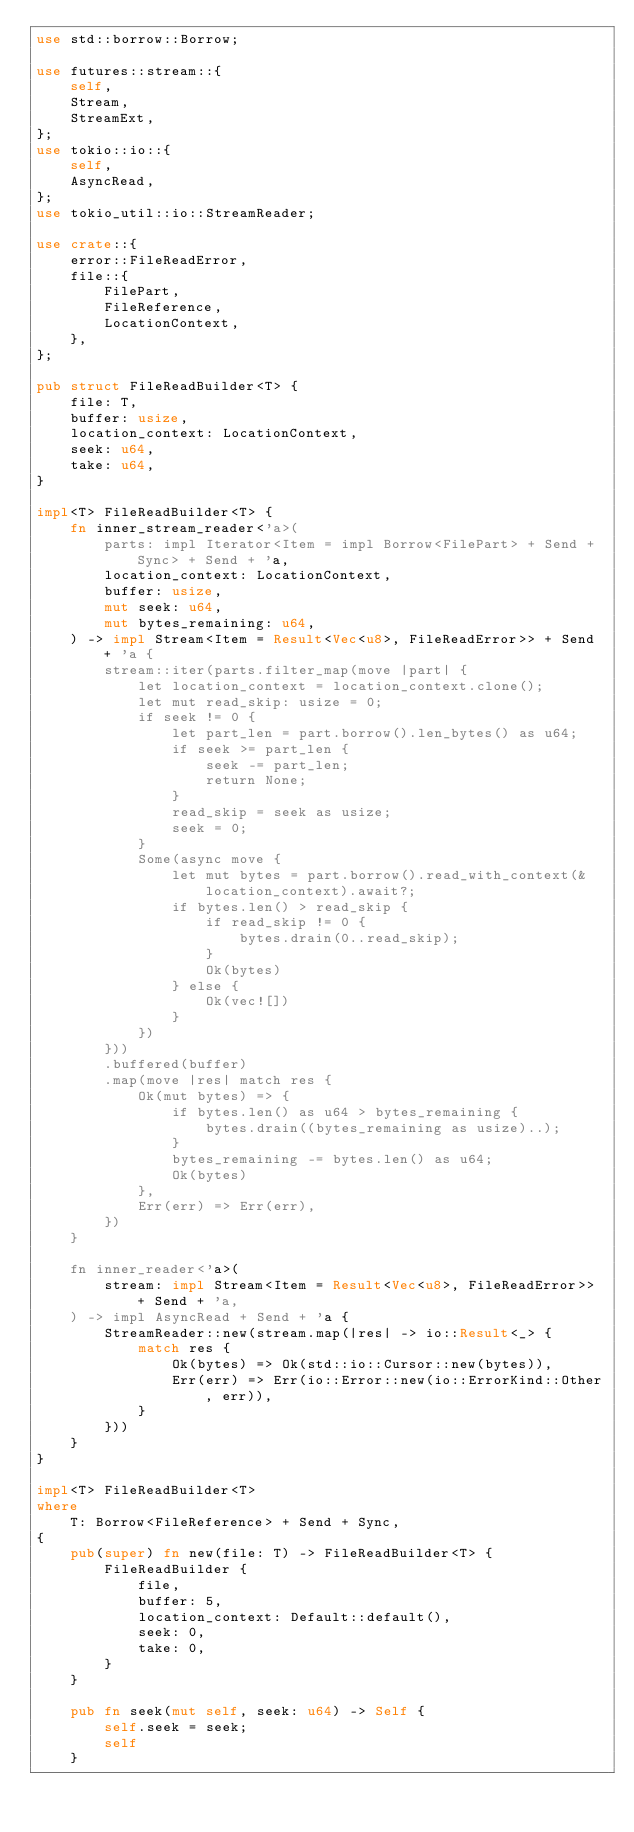<code> <loc_0><loc_0><loc_500><loc_500><_Rust_>use std::borrow::Borrow;

use futures::stream::{
    self,
    Stream,
    StreamExt,
};
use tokio::io::{
    self,
    AsyncRead,
};
use tokio_util::io::StreamReader;

use crate::{
    error::FileReadError,
    file::{
        FilePart,
        FileReference,
        LocationContext,
    },
};

pub struct FileReadBuilder<T> {
    file: T,
    buffer: usize,
    location_context: LocationContext,
    seek: u64,
    take: u64,
}

impl<T> FileReadBuilder<T> {
    fn inner_stream_reader<'a>(
        parts: impl Iterator<Item = impl Borrow<FilePart> + Send + Sync> + Send + 'a,
        location_context: LocationContext,
        buffer: usize,
        mut seek: u64,
        mut bytes_remaining: u64,
    ) -> impl Stream<Item = Result<Vec<u8>, FileReadError>> + Send + 'a {
        stream::iter(parts.filter_map(move |part| {
            let location_context = location_context.clone();
            let mut read_skip: usize = 0;
            if seek != 0 {
                let part_len = part.borrow().len_bytes() as u64;
                if seek >= part_len {
                    seek -= part_len;
                    return None;
                }
                read_skip = seek as usize;
                seek = 0;
            }
            Some(async move {
                let mut bytes = part.borrow().read_with_context(&location_context).await?;
                if bytes.len() > read_skip {
                    if read_skip != 0 {
                        bytes.drain(0..read_skip);
                    }
                    Ok(bytes)
                } else {
                    Ok(vec![])
                }
            })
        }))
        .buffered(buffer)
        .map(move |res| match res {
            Ok(mut bytes) => {
                if bytes.len() as u64 > bytes_remaining {
                    bytes.drain((bytes_remaining as usize)..);
                }
                bytes_remaining -= bytes.len() as u64;
                Ok(bytes)
            },
            Err(err) => Err(err),
        })
    }

    fn inner_reader<'a>(
        stream: impl Stream<Item = Result<Vec<u8>, FileReadError>> + Send + 'a,
    ) -> impl AsyncRead + Send + 'a {
        StreamReader::new(stream.map(|res| -> io::Result<_> {
            match res {
                Ok(bytes) => Ok(std::io::Cursor::new(bytes)),
                Err(err) => Err(io::Error::new(io::ErrorKind::Other, err)),
            }
        }))
    }
}

impl<T> FileReadBuilder<T>
where
    T: Borrow<FileReference> + Send + Sync,
{
    pub(super) fn new(file: T) -> FileReadBuilder<T> {
        FileReadBuilder {
            file,
            buffer: 5,
            location_context: Default::default(),
            seek: 0,
            take: 0,
        }
    }

    pub fn seek(mut self, seek: u64) -> Self {
        self.seek = seek;
        self
    }
</code> 